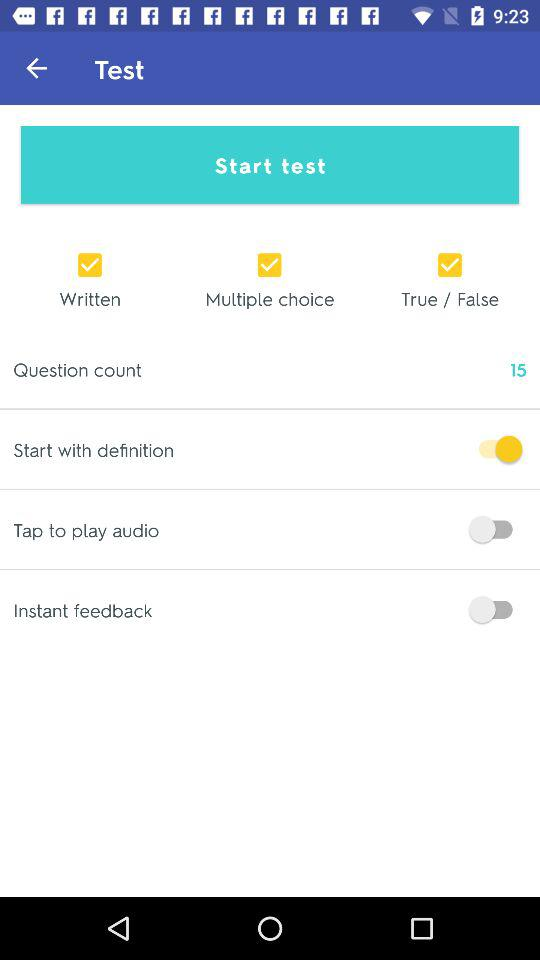How many test types are available?
Answer the question using a single word or phrase. 3 